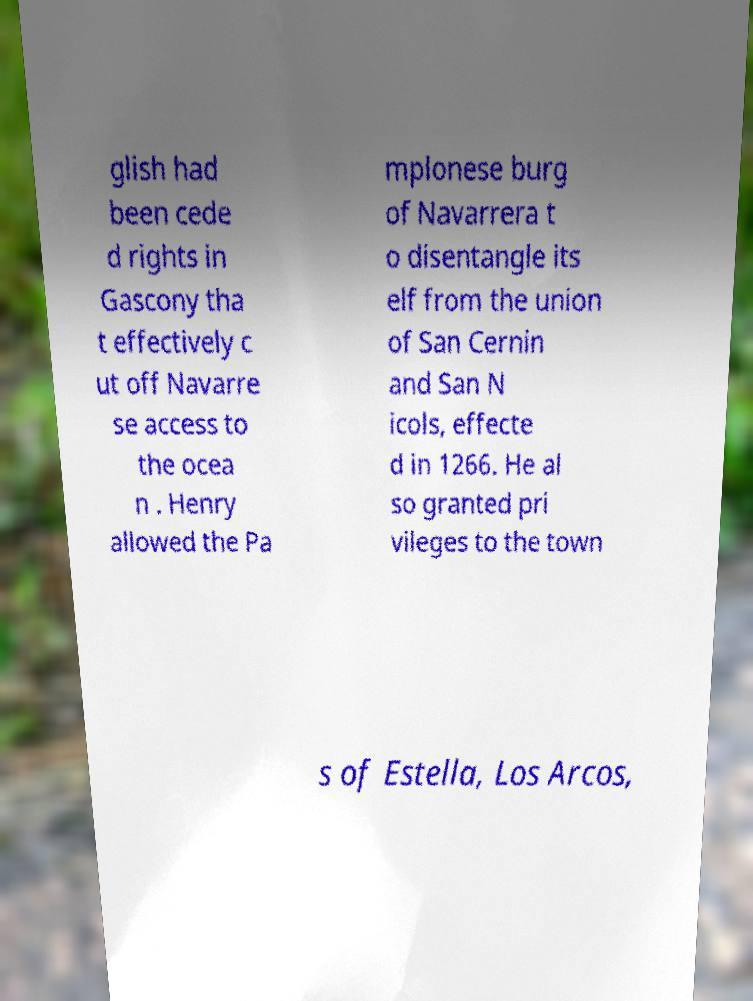Could you assist in decoding the text presented in this image and type it out clearly? glish had been cede d rights in Gascony tha t effectively c ut off Navarre se access to the ocea n . Henry allowed the Pa mplonese burg of Navarrera t o disentangle its elf from the union of San Cernin and San N icols, effecte d in 1266. He al so granted pri vileges to the town s of Estella, Los Arcos, 